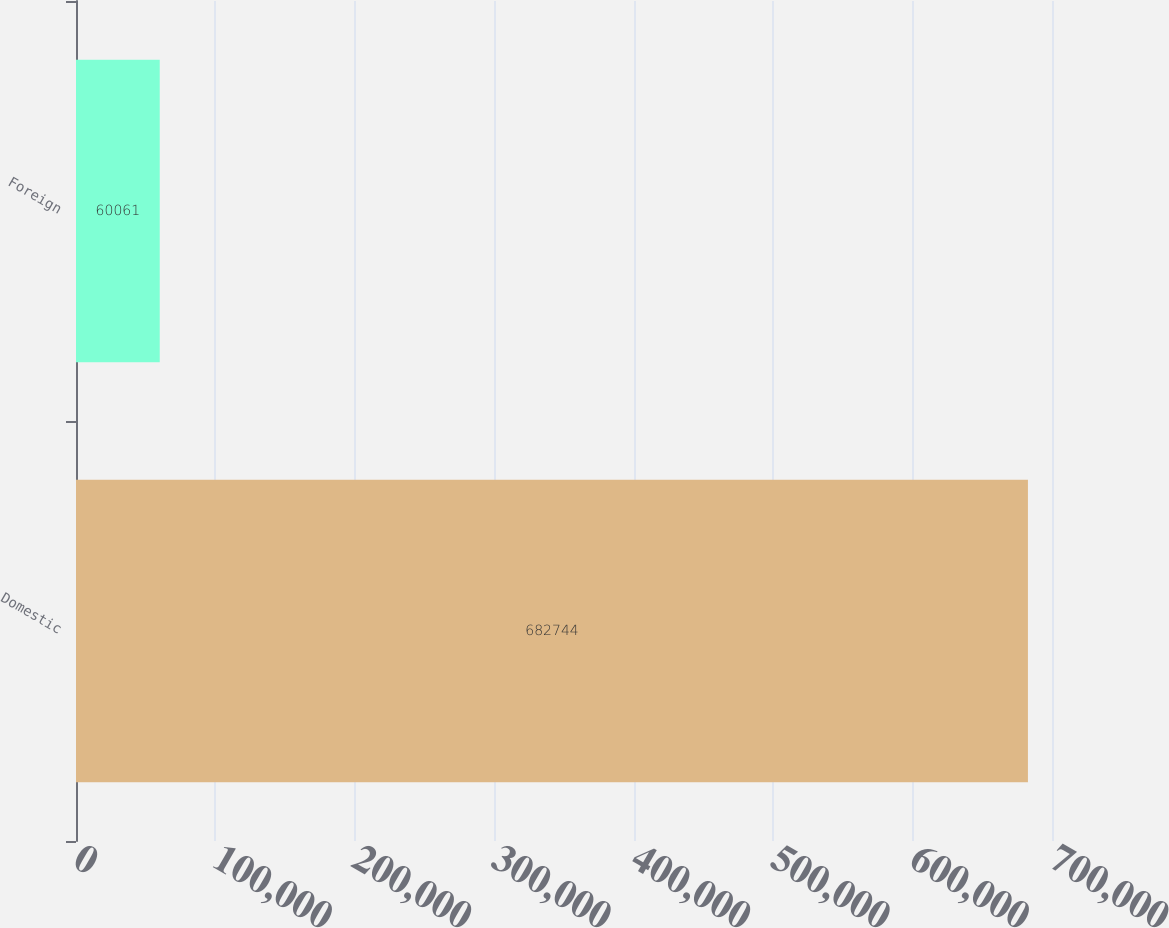Convert chart to OTSL. <chart><loc_0><loc_0><loc_500><loc_500><bar_chart><fcel>Domestic<fcel>Foreign<nl><fcel>682744<fcel>60061<nl></chart> 